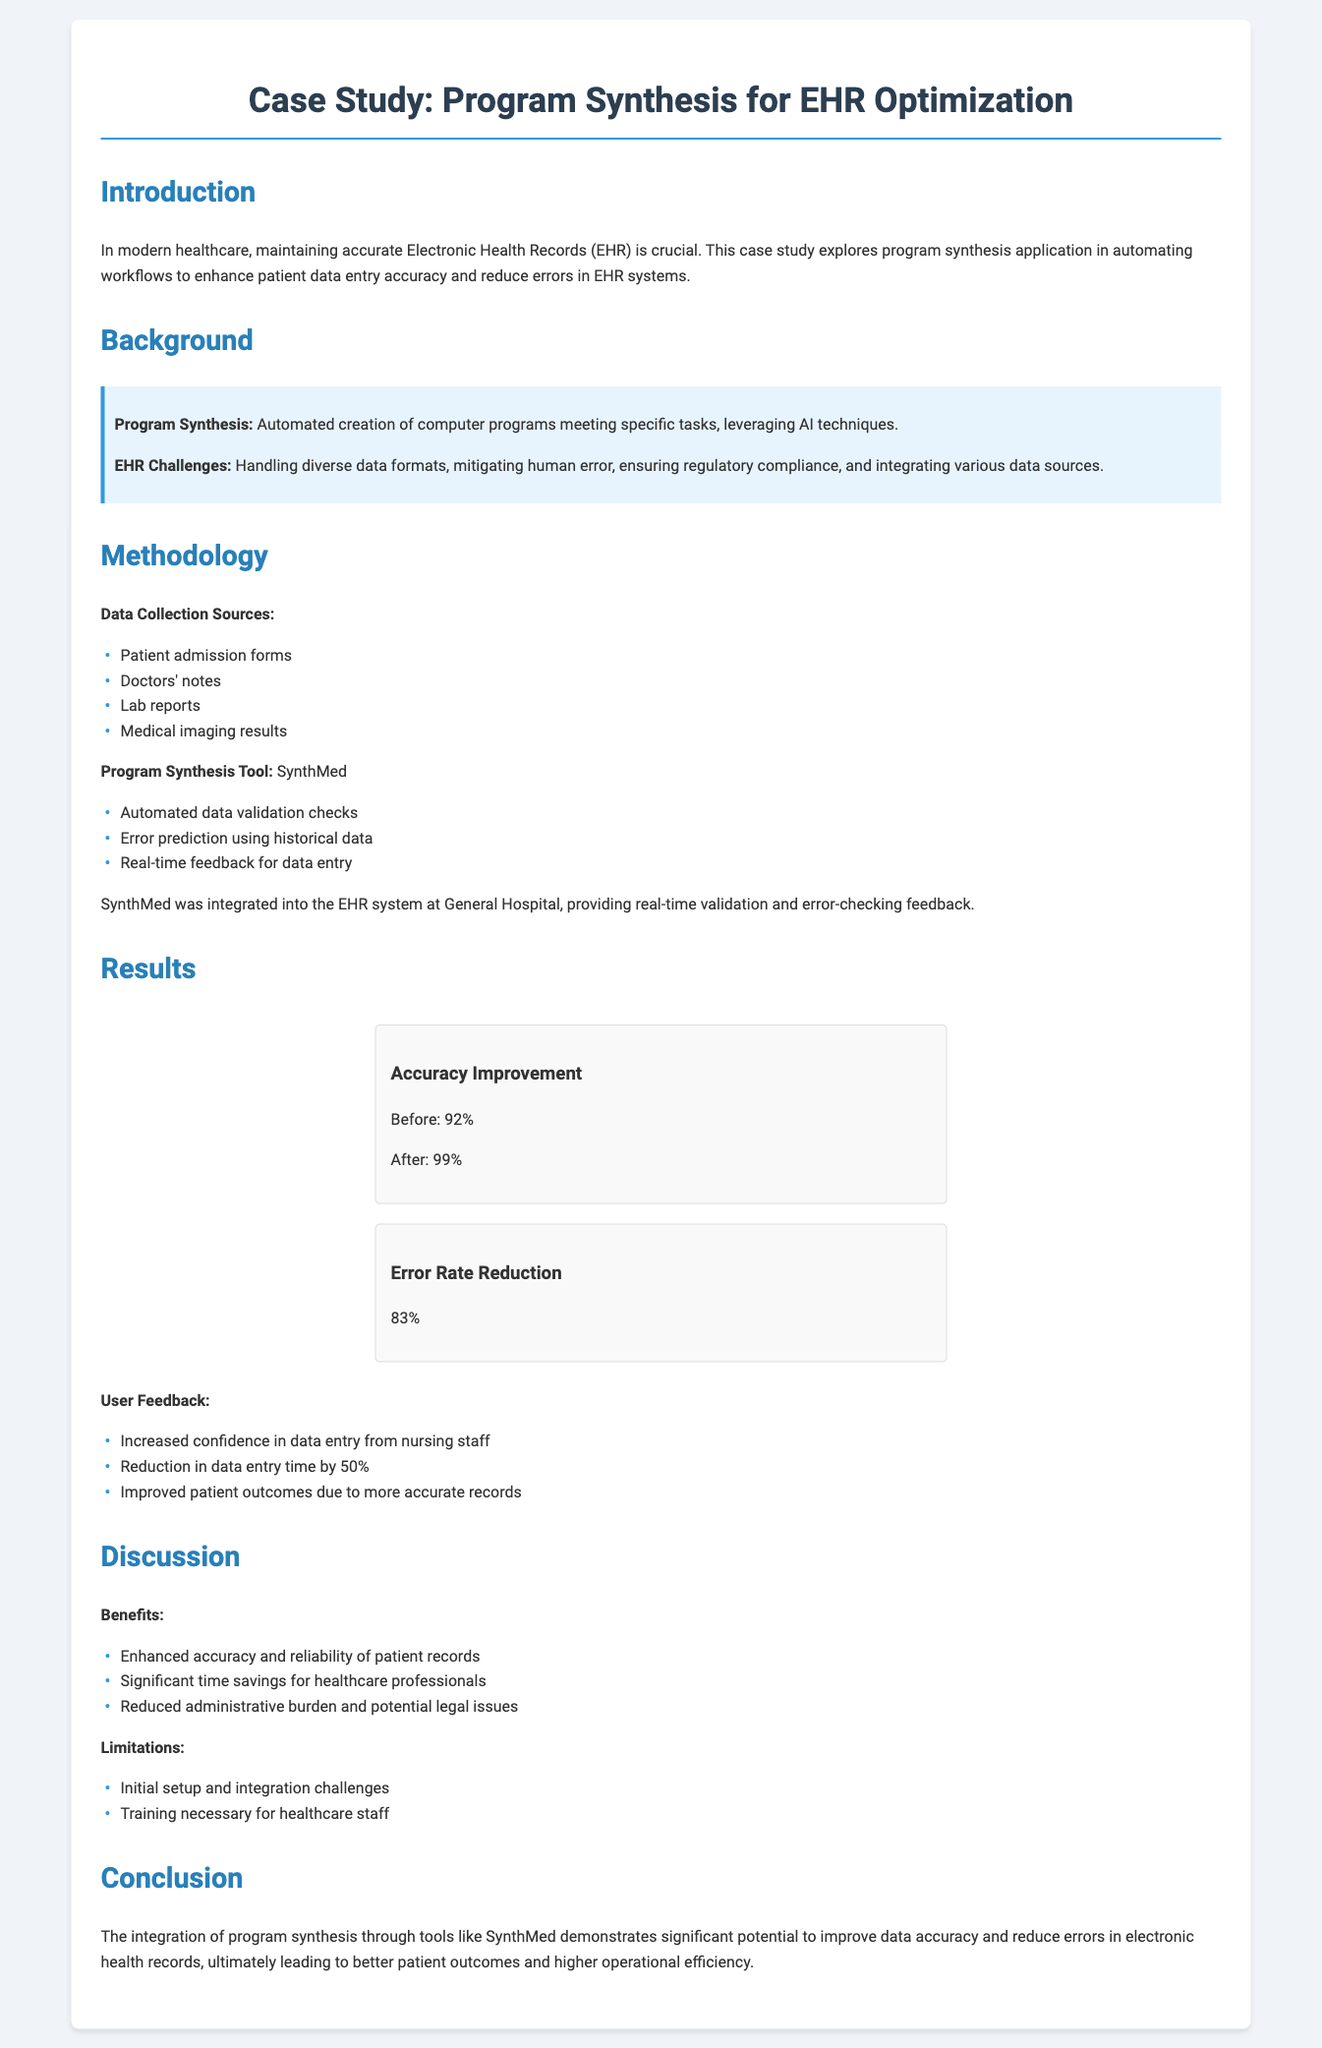What is the title of the case study? The title is found in the header section of the document, which specifies the focus of the case study.
Answer: Case Study: Program Synthesis for EHR Optimization What tool was used for program synthesis in the study? The tool is specifically mentioned within the methodology section that describes its integration and functionalities.
Answer: SynthMed What was the accuracy improvement percentage after using the program? The accuracy improvement is detailed in the results section, showing the performance before and after the intervention.
Answer: 7% How much time was reduced in data entry? The reduced data entry time is listed in the user feedback section, indicating the efficiency gains resulting from the implementation.
Answer: 50% What is one of the challenges mentioned in the limitations? The limitations section outlines obstacles faced during the integration of the program synthesis tool into the existing systems.
Answer: Initial setup challenges What percentage reduction in error rate was achieved? The error rate reduction is presented in the results section, providing a clear numerical measurement of success.
Answer: 83% What kind of feedback did nursing staff give after the implementation? The user feedback section summarizes the responses of healthcare professionals regarding their experience after the tool was integrated.
Answer: Increased confidence What are the EHR challenges mentioned in the background? The background section highlights various issues that EHR systems encounter, providing context for the study.
Answer: Diverse data formats What is one benefit of program synthesis mentioned in the discussion? The benefits listed in the discussion section describe the positive impacts observed from the program synthesis application.
Answer: Enhanced accuracy 